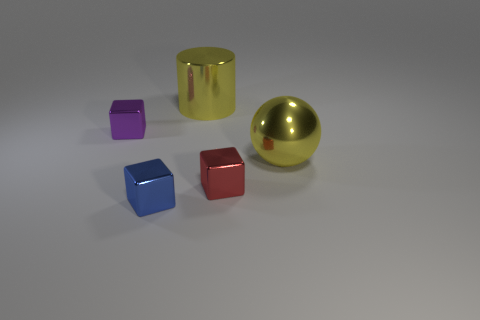How many other objects are the same size as the blue thing?
Offer a terse response. 2. What number of cubes are small purple rubber things or tiny purple objects?
Make the answer very short. 1. Is there any other thing that has the same material as the red block?
Keep it short and to the point. Yes. What is the material of the big thing that is on the left side of the small block on the right side of the thing that is in front of the red metal cube?
Offer a very short reply. Metal. There is a big cylinder that is the same color as the shiny sphere; what material is it?
Your answer should be very brief. Metal. How many purple cubes are made of the same material as the large cylinder?
Provide a short and direct response. 1. Do the metal thing on the left side of the blue metal cube and the small red cube have the same size?
Make the answer very short. Yes. What color is the large sphere that is the same material as the blue object?
Provide a short and direct response. Yellow. Is there anything else that has the same size as the yellow cylinder?
Offer a terse response. Yes. There is a metal cylinder; how many small blue blocks are in front of it?
Keep it short and to the point. 1. 